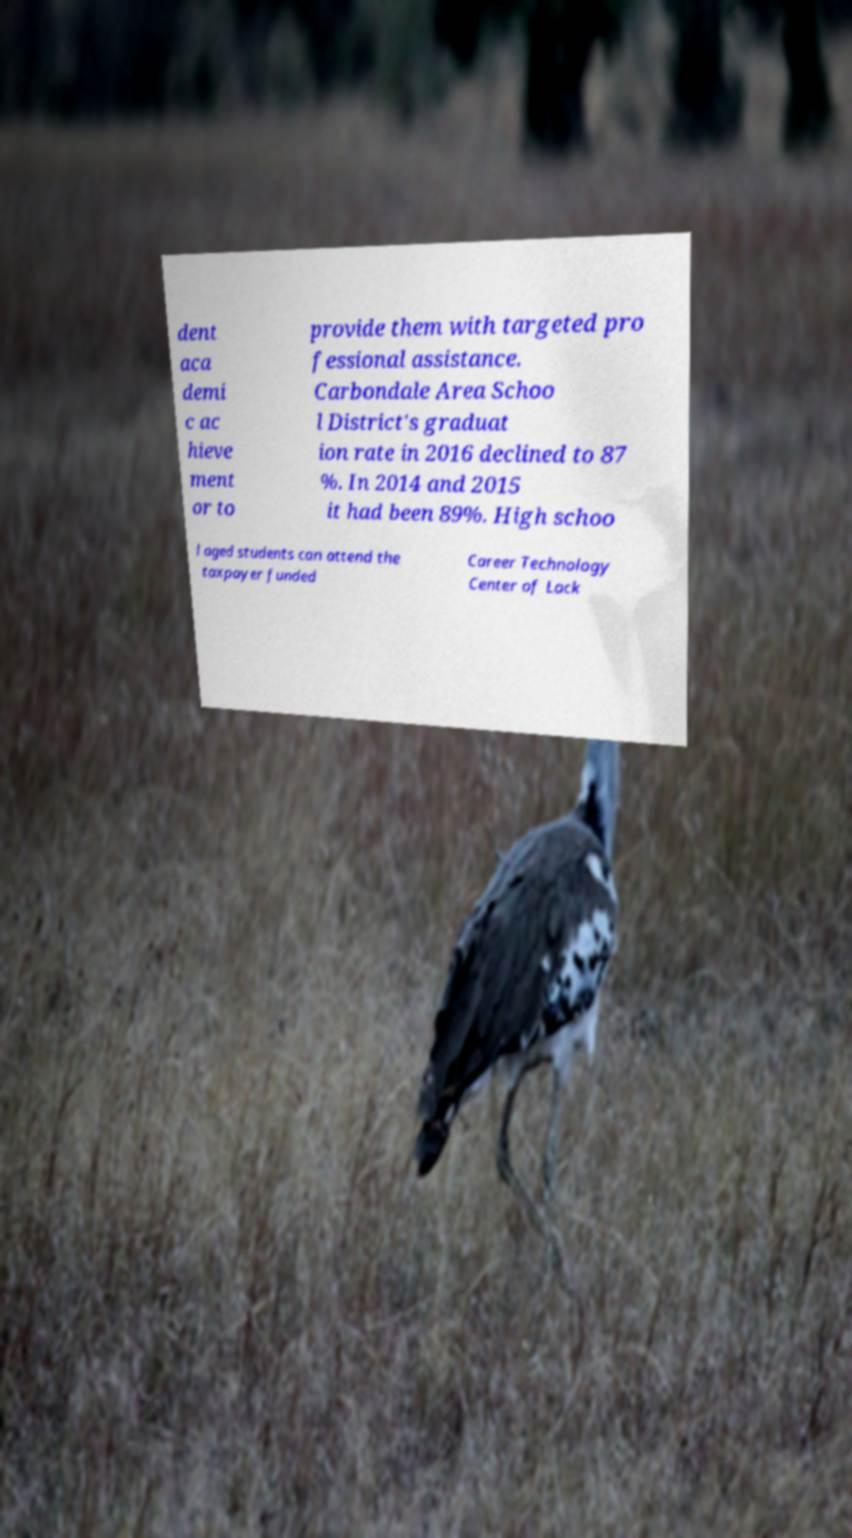There's text embedded in this image that I need extracted. Can you transcribe it verbatim? dent aca demi c ac hieve ment or to provide them with targeted pro fessional assistance. Carbondale Area Schoo l District's graduat ion rate in 2016 declined to 87 %. In 2014 and 2015 it had been 89%. High schoo l aged students can attend the taxpayer funded Career Technology Center of Lack 